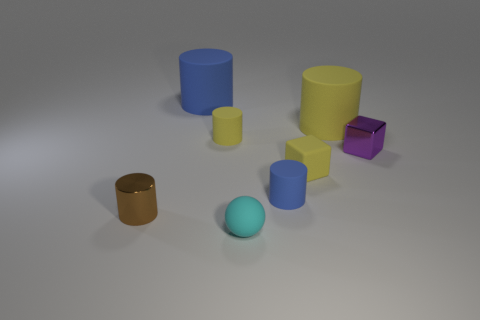Subtract 1 cylinders. How many cylinders are left? 4 Subtract all cyan cylinders. Subtract all green cubes. How many cylinders are left? 5 Add 1 big rubber things. How many objects exist? 9 Subtract all blocks. How many objects are left? 6 Subtract 0 brown balls. How many objects are left? 8 Subtract all big yellow objects. Subtract all purple metallic objects. How many objects are left? 6 Add 3 brown shiny objects. How many brown shiny objects are left? 4 Add 3 matte blocks. How many matte blocks exist? 4 